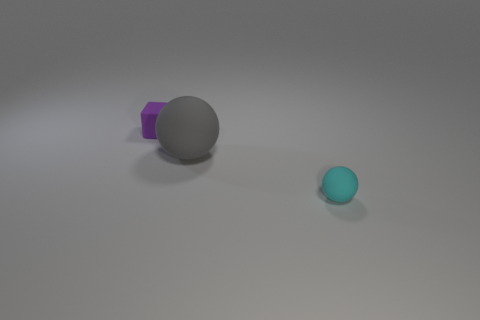How many tiny cyan objects are the same shape as the gray thing?
Your answer should be very brief. 1. How many objects are either small objects in front of the small purple rubber cube or matte things that are behind the small cyan thing?
Offer a terse response. 3. What number of small cyan objects are behind the tiny matte object behind the large thing?
Provide a short and direct response. 0. Is the shape of the small thing that is right of the cube the same as the gray matte object behind the small cyan thing?
Provide a succinct answer. Yes. Is there a cyan thing made of the same material as the big gray thing?
Give a very brief answer. Yes. What number of shiny objects are tiny gray objects or big gray spheres?
Make the answer very short. 0. What shape is the small rubber thing in front of the small matte object that is behind the big object?
Give a very brief answer. Sphere. Is the number of gray matte things on the left side of the cube less than the number of shiny cylinders?
Provide a succinct answer. No. There is a cyan matte thing; what shape is it?
Your response must be concise. Sphere. What is the size of the object behind the gray object?
Provide a succinct answer. Small. 